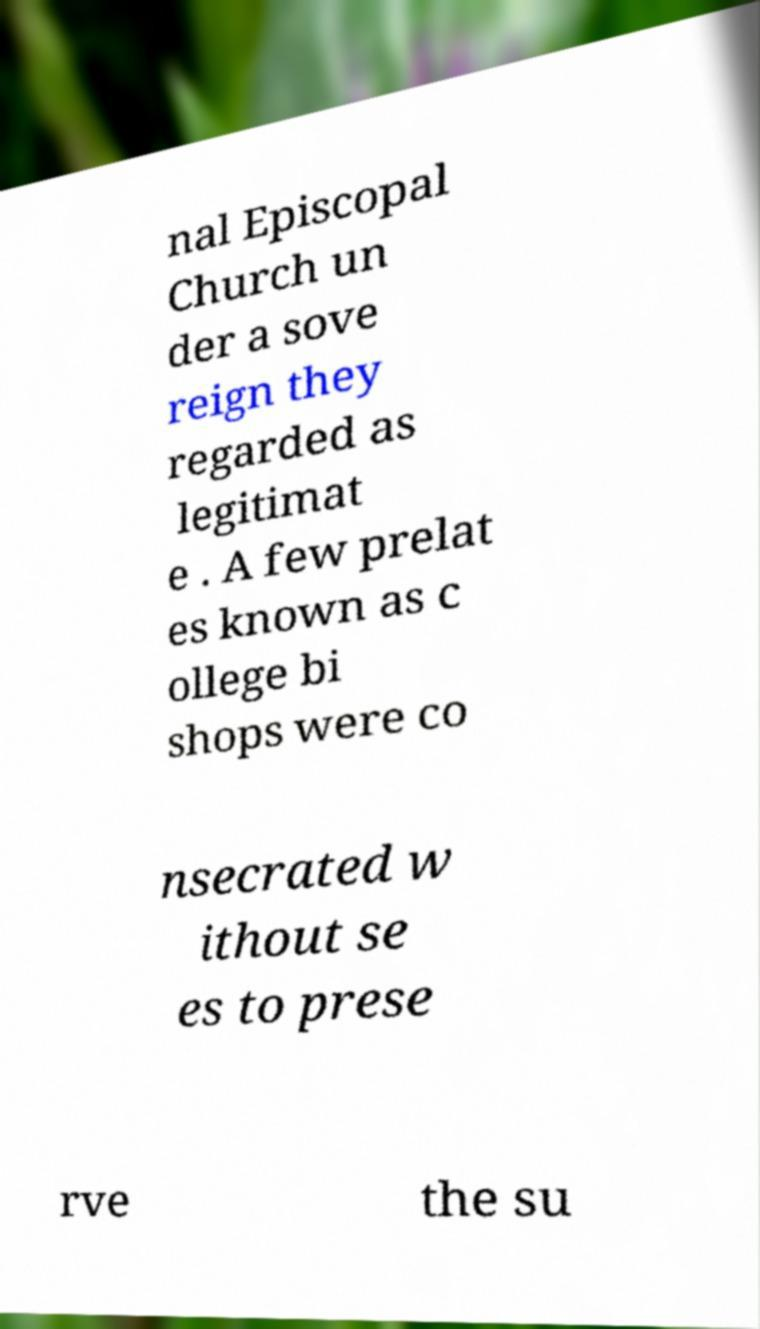What messages or text are displayed in this image? I need them in a readable, typed format. nal Episcopal Church un der a sove reign they regarded as legitimat e . A few prelat es known as c ollege bi shops were co nsecrated w ithout se es to prese rve the su 